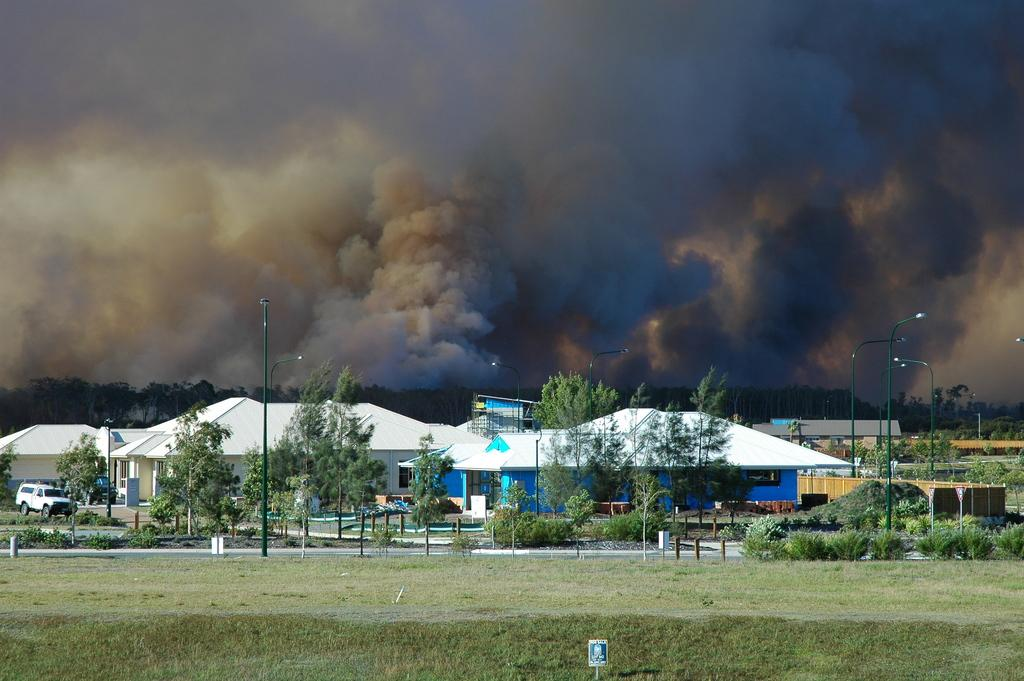What can be seen in the foreground of the image? In the foreground of the image, there is grass, light poles, plants, trees, vehicles, and houses. Can you describe the vegetation in the foreground? The vegetation in the foreground includes grass, plants, and trees. What is visible on the road in the foreground? There are vehicles on the road in the foreground of the image. What can be seen in the background of the image? In the background of the image, there is smoke and the sky. When was the image taken? The image was taken during the day. What type of hen can be seen sitting on the dock in the image? There is no hen or dock present in the image. What scent is associated with the smoke in the background of the image? The image does not provide information about the scent of the smoke. 